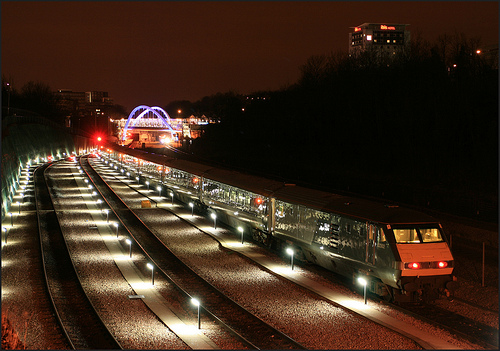What might the lit-up structure in the background be? The illuminated structure in the background has a distinctive arch shape, suggesting it could be a bridge or an entryway of some kind, possibly used for transportation or as a landmark. 